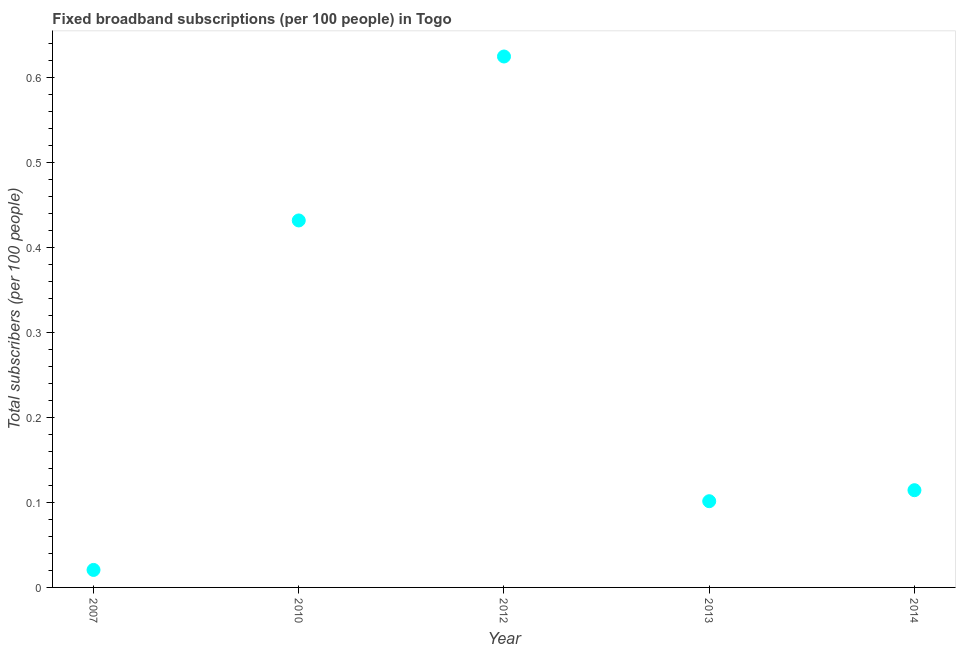What is the total number of fixed broadband subscriptions in 2010?
Provide a succinct answer. 0.43. Across all years, what is the maximum total number of fixed broadband subscriptions?
Provide a succinct answer. 0.62. Across all years, what is the minimum total number of fixed broadband subscriptions?
Offer a terse response. 0.02. What is the sum of the total number of fixed broadband subscriptions?
Offer a terse response. 1.29. What is the difference between the total number of fixed broadband subscriptions in 2007 and 2010?
Your response must be concise. -0.41. What is the average total number of fixed broadband subscriptions per year?
Give a very brief answer. 0.26. What is the median total number of fixed broadband subscriptions?
Keep it short and to the point. 0.11. In how many years, is the total number of fixed broadband subscriptions greater than 0.6000000000000001 ?
Keep it short and to the point. 1. What is the ratio of the total number of fixed broadband subscriptions in 2007 to that in 2010?
Your answer should be very brief. 0.05. What is the difference between the highest and the second highest total number of fixed broadband subscriptions?
Keep it short and to the point. 0.19. What is the difference between the highest and the lowest total number of fixed broadband subscriptions?
Offer a very short reply. 0.6. In how many years, is the total number of fixed broadband subscriptions greater than the average total number of fixed broadband subscriptions taken over all years?
Make the answer very short. 2. Does the total number of fixed broadband subscriptions monotonically increase over the years?
Give a very brief answer. No. How many dotlines are there?
Your answer should be compact. 1. How many years are there in the graph?
Provide a short and direct response. 5. What is the difference between two consecutive major ticks on the Y-axis?
Your response must be concise. 0.1. What is the title of the graph?
Provide a short and direct response. Fixed broadband subscriptions (per 100 people) in Togo. What is the label or title of the X-axis?
Keep it short and to the point. Year. What is the label or title of the Y-axis?
Provide a succinct answer. Total subscribers (per 100 people). What is the Total subscribers (per 100 people) in 2007?
Make the answer very short. 0.02. What is the Total subscribers (per 100 people) in 2010?
Offer a terse response. 0.43. What is the Total subscribers (per 100 people) in 2012?
Provide a succinct answer. 0.62. What is the Total subscribers (per 100 people) in 2013?
Give a very brief answer. 0.1. What is the Total subscribers (per 100 people) in 2014?
Make the answer very short. 0.11. What is the difference between the Total subscribers (per 100 people) in 2007 and 2010?
Offer a very short reply. -0.41. What is the difference between the Total subscribers (per 100 people) in 2007 and 2012?
Give a very brief answer. -0.6. What is the difference between the Total subscribers (per 100 people) in 2007 and 2013?
Make the answer very short. -0.08. What is the difference between the Total subscribers (per 100 people) in 2007 and 2014?
Keep it short and to the point. -0.09. What is the difference between the Total subscribers (per 100 people) in 2010 and 2012?
Offer a terse response. -0.19. What is the difference between the Total subscribers (per 100 people) in 2010 and 2013?
Your answer should be compact. 0.33. What is the difference between the Total subscribers (per 100 people) in 2010 and 2014?
Provide a succinct answer. 0.32. What is the difference between the Total subscribers (per 100 people) in 2012 and 2013?
Make the answer very short. 0.52. What is the difference between the Total subscribers (per 100 people) in 2012 and 2014?
Your response must be concise. 0.51. What is the difference between the Total subscribers (per 100 people) in 2013 and 2014?
Offer a very short reply. -0.01. What is the ratio of the Total subscribers (per 100 people) in 2007 to that in 2010?
Provide a short and direct response. 0.05. What is the ratio of the Total subscribers (per 100 people) in 2007 to that in 2012?
Provide a succinct answer. 0.03. What is the ratio of the Total subscribers (per 100 people) in 2007 to that in 2013?
Ensure brevity in your answer.  0.2. What is the ratio of the Total subscribers (per 100 people) in 2007 to that in 2014?
Give a very brief answer. 0.18. What is the ratio of the Total subscribers (per 100 people) in 2010 to that in 2012?
Your response must be concise. 0.69. What is the ratio of the Total subscribers (per 100 people) in 2010 to that in 2013?
Your answer should be compact. 4.26. What is the ratio of the Total subscribers (per 100 people) in 2010 to that in 2014?
Your answer should be very brief. 3.77. What is the ratio of the Total subscribers (per 100 people) in 2012 to that in 2013?
Offer a terse response. 6.16. What is the ratio of the Total subscribers (per 100 people) in 2012 to that in 2014?
Ensure brevity in your answer.  5.46. What is the ratio of the Total subscribers (per 100 people) in 2013 to that in 2014?
Offer a terse response. 0.89. 